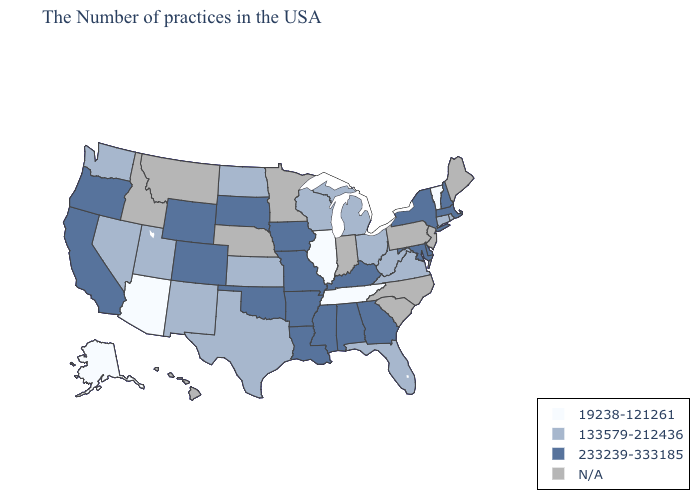What is the value of Montana?
Keep it brief. N/A. Does the first symbol in the legend represent the smallest category?
Give a very brief answer. Yes. Name the states that have a value in the range N/A?
Be succinct. Maine, New Jersey, Pennsylvania, North Carolina, South Carolina, Indiana, Minnesota, Nebraska, Montana, Idaho, Hawaii. Among the states that border Arkansas , which have the highest value?
Quick response, please. Mississippi, Louisiana, Missouri, Oklahoma. Does Vermont have the highest value in the Northeast?
Write a very short answer. No. What is the highest value in states that border Oregon?
Give a very brief answer. 233239-333185. Name the states that have a value in the range 233239-333185?
Concise answer only. Massachusetts, New Hampshire, New York, Delaware, Maryland, Georgia, Kentucky, Alabama, Mississippi, Louisiana, Missouri, Arkansas, Iowa, Oklahoma, South Dakota, Wyoming, Colorado, California, Oregon. What is the value of Montana?
Keep it brief. N/A. Which states hav the highest value in the Northeast?
Quick response, please. Massachusetts, New Hampshire, New York. What is the value of Maryland?
Be succinct. 233239-333185. Name the states that have a value in the range N/A?
Concise answer only. Maine, New Jersey, Pennsylvania, North Carolina, South Carolina, Indiana, Minnesota, Nebraska, Montana, Idaho, Hawaii. What is the value of Virginia?
Concise answer only. 133579-212436. What is the value of Arkansas?
Quick response, please. 233239-333185. Does the first symbol in the legend represent the smallest category?
Concise answer only. Yes. 